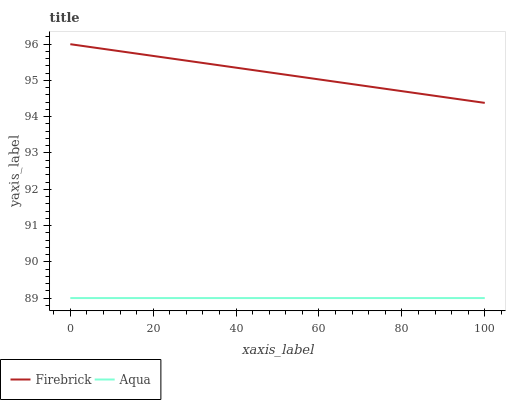Does Aqua have the minimum area under the curve?
Answer yes or no. Yes. Does Firebrick have the maximum area under the curve?
Answer yes or no. Yes. Does Aqua have the maximum area under the curve?
Answer yes or no. No. Is Aqua the smoothest?
Answer yes or no. Yes. Is Firebrick the roughest?
Answer yes or no. Yes. Is Aqua the roughest?
Answer yes or no. No. Does Aqua have the lowest value?
Answer yes or no. Yes. Does Firebrick have the highest value?
Answer yes or no. Yes. Does Aqua have the highest value?
Answer yes or no. No. Is Aqua less than Firebrick?
Answer yes or no. Yes. Is Firebrick greater than Aqua?
Answer yes or no. Yes. Does Aqua intersect Firebrick?
Answer yes or no. No. 